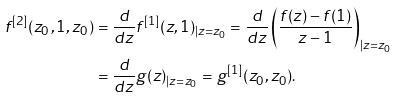<formula> <loc_0><loc_0><loc_500><loc_500>f ^ { [ 2 ] } ( z _ { 0 } , 1 , z _ { 0 } ) & = \frac { d } { d z } f ^ { [ 1 ] } ( z , 1 ) _ { | z = z _ { 0 } } = \frac { d } { d z } \left ( \frac { f ( z ) - f ( 1 ) } { z - 1 } \right ) _ { | z = z _ { 0 } } \\ & = \frac { d } { d z } g ( z ) _ { | z = z _ { 0 } } = g ^ { [ 1 ] } ( z _ { 0 } , z _ { 0 } ) .</formula> 